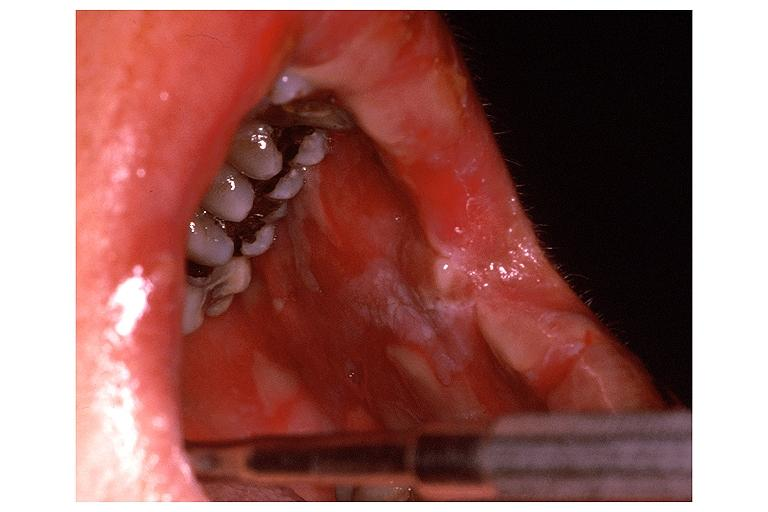does this image show erythema multiforme?
Answer the question using a single word or phrase. Yes 